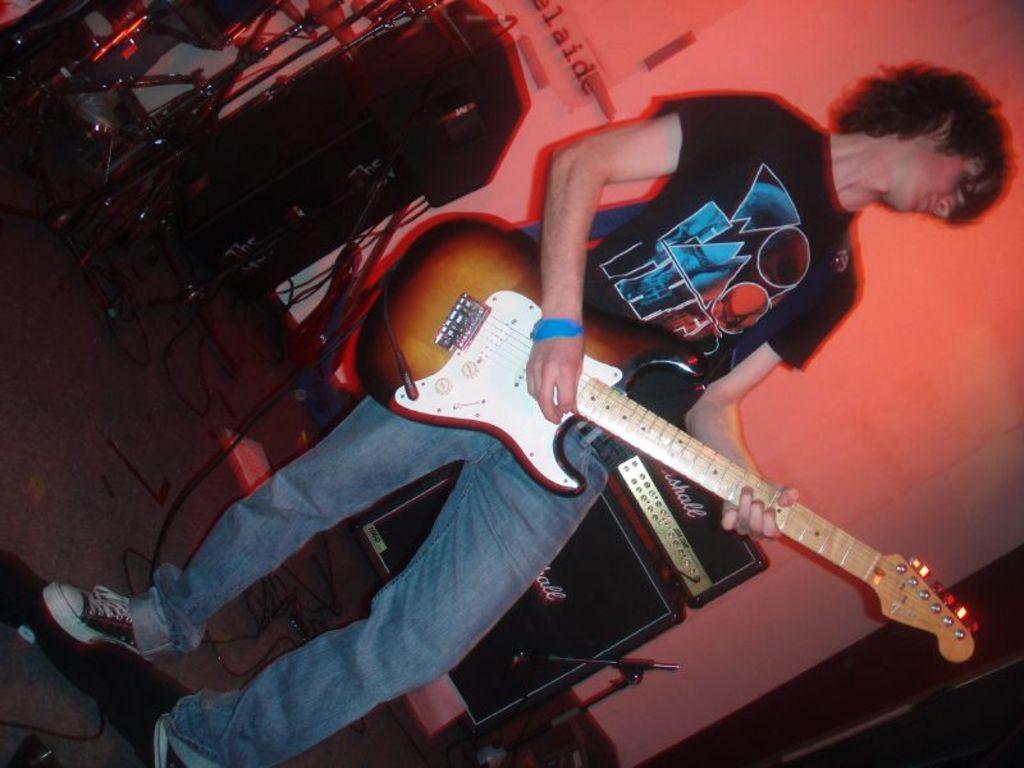Could you give a brief overview of what you see in this image? In this picture there is a boy wearing a black color t-shirt, standing and playing a guitar. Behind there is a black color music instruments. In the background we can see the white color wall. 